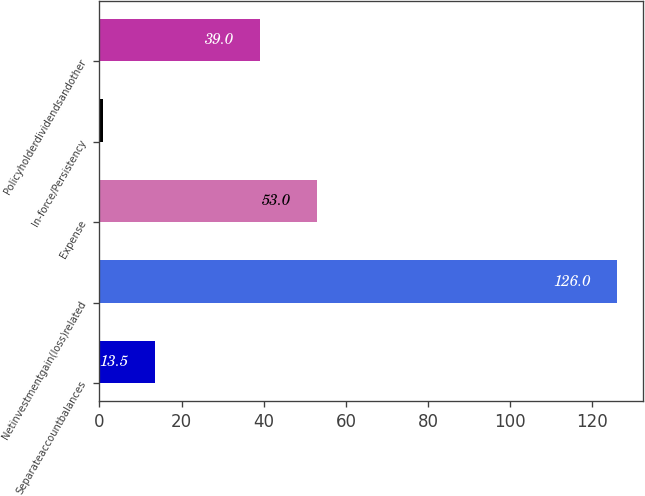Convert chart. <chart><loc_0><loc_0><loc_500><loc_500><bar_chart><fcel>Separateaccountbalances<fcel>Netinvestmentgain(loss)related<fcel>Expense<fcel>In-force/Persistency<fcel>Policyholderdividendsandother<nl><fcel>13.5<fcel>126<fcel>53<fcel>1<fcel>39<nl></chart> 